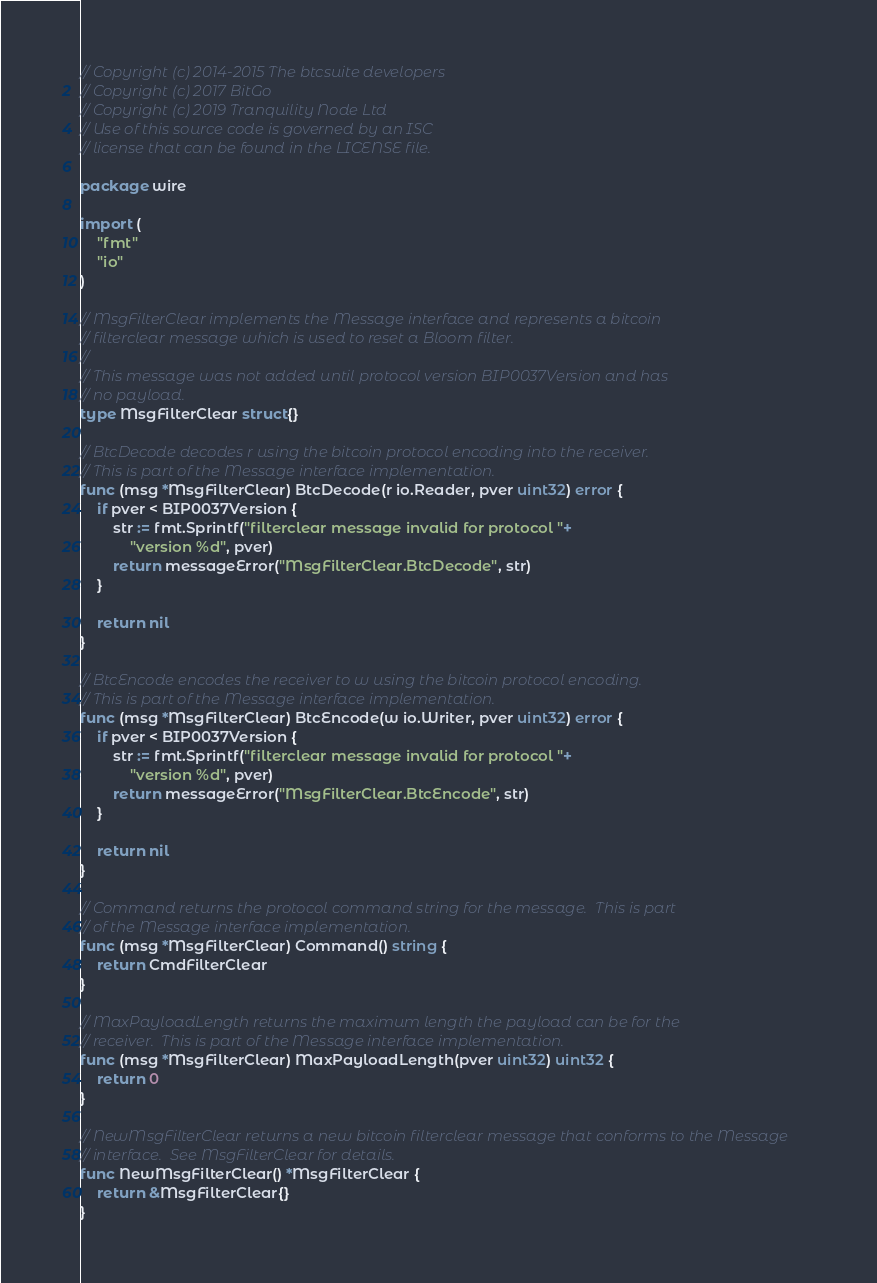<code> <loc_0><loc_0><loc_500><loc_500><_Go_>// Copyright (c) 2014-2015 The btcsuite developers
// Copyright (c) 2017 BitGo
// Copyright (c) 2019 Tranquility Node Ltd
// Use of this source code is governed by an ISC
// license that can be found in the LICENSE file.

package wire

import (
	"fmt"
	"io"
)

// MsgFilterClear implements the Message interface and represents a bitcoin
// filterclear message which is used to reset a Bloom filter.
//
// This message was not added until protocol version BIP0037Version and has
// no payload.
type MsgFilterClear struct{}

// BtcDecode decodes r using the bitcoin protocol encoding into the receiver.
// This is part of the Message interface implementation.
func (msg *MsgFilterClear) BtcDecode(r io.Reader, pver uint32) error {
	if pver < BIP0037Version {
		str := fmt.Sprintf("filterclear message invalid for protocol "+
			"version %d", pver)
		return messageError("MsgFilterClear.BtcDecode", str)
	}

	return nil
}

// BtcEncode encodes the receiver to w using the bitcoin protocol encoding.
// This is part of the Message interface implementation.
func (msg *MsgFilterClear) BtcEncode(w io.Writer, pver uint32) error {
	if pver < BIP0037Version {
		str := fmt.Sprintf("filterclear message invalid for protocol "+
			"version %d", pver)
		return messageError("MsgFilterClear.BtcEncode", str)
	}

	return nil
}

// Command returns the protocol command string for the message.  This is part
// of the Message interface implementation.
func (msg *MsgFilterClear) Command() string {
	return CmdFilterClear
}

// MaxPayloadLength returns the maximum length the payload can be for the
// receiver.  This is part of the Message interface implementation.
func (msg *MsgFilterClear) MaxPayloadLength(pver uint32) uint32 {
	return 0
}

// NewMsgFilterClear returns a new bitcoin filterclear message that conforms to the Message
// interface.  See MsgFilterClear for details.
func NewMsgFilterClear() *MsgFilterClear {
	return &MsgFilterClear{}
}
</code> 